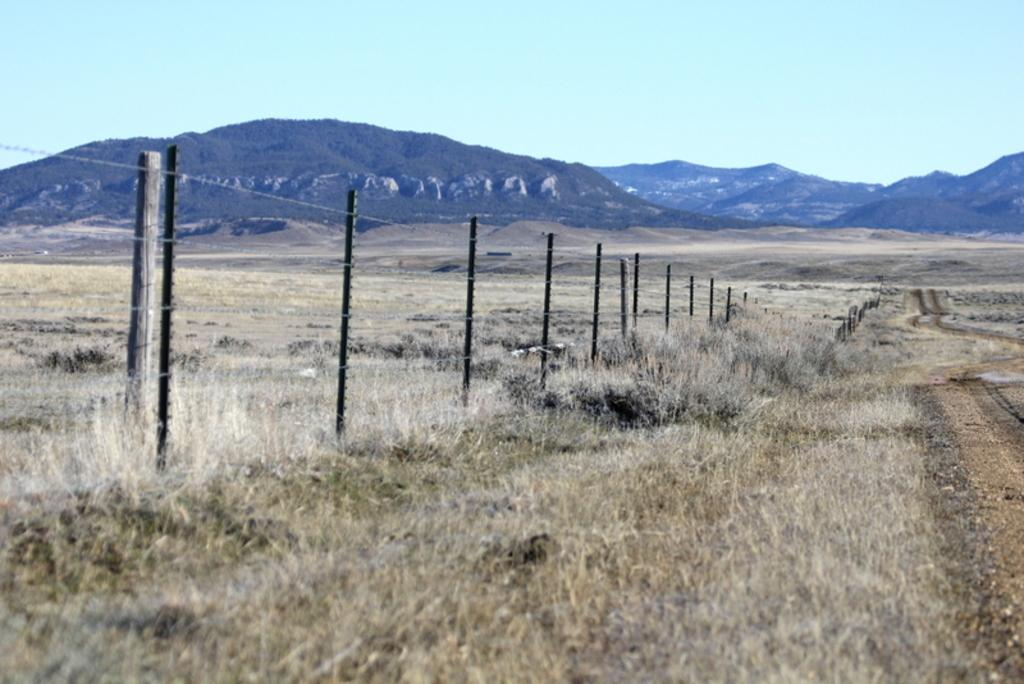What type of terrain is visible in the image? There is grass on the ground in the image. What type of structure can be seen in the image? There is a fence visible in the image. What geographical features are present in the image? There are hills and trees in the image. What is the condition of the sky in the image? The sky is blue and cloudy in the image. What is the topic of the discussion taking place in the image? There is no discussion taking place in the image; it is a still image of a landscape. How many rocks can be seen in the image? There are no rocks visible in the image. 